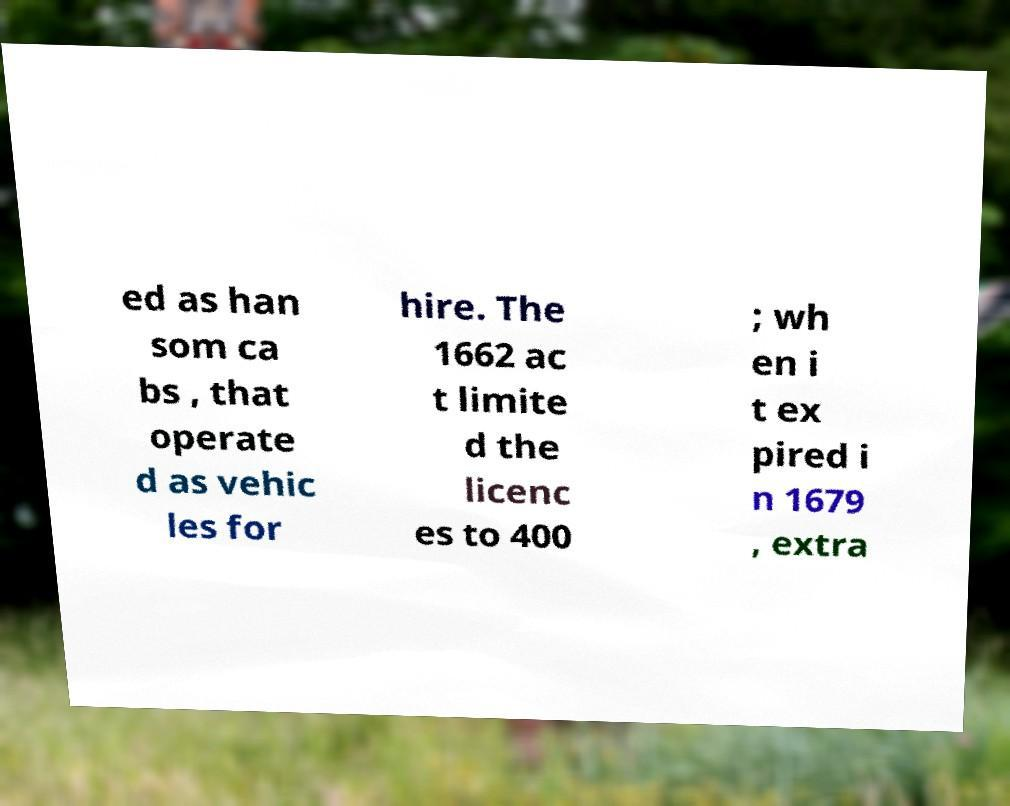I need the written content from this picture converted into text. Can you do that? ed as han som ca bs , that operate d as vehic les for hire. The 1662 ac t limite d the licenc es to 400 ; wh en i t ex pired i n 1679 , extra 